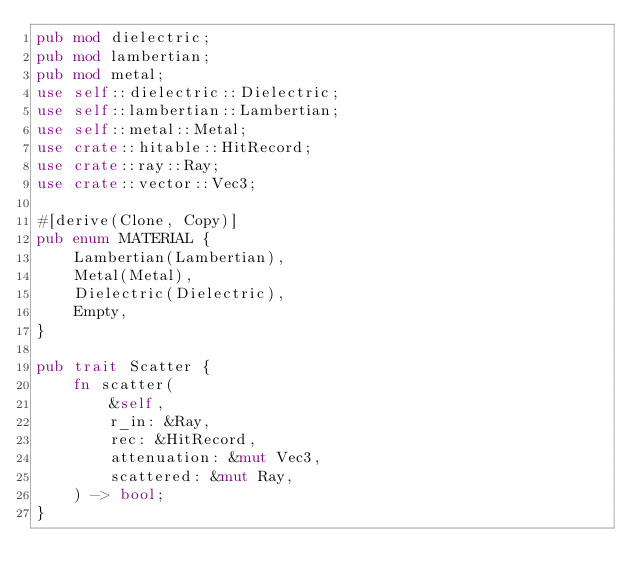Convert code to text. <code><loc_0><loc_0><loc_500><loc_500><_Rust_>pub mod dielectric;
pub mod lambertian;
pub mod metal;
use self::dielectric::Dielectric;
use self::lambertian::Lambertian;
use self::metal::Metal;
use crate::hitable::HitRecord;
use crate::ray::Ray;
use crate::vector::Vec3;

#[derive(Clone, Copy)]
pub enum MATERIAL {
    Lambertian(Lambertian),
    Metal(Metal),
    Dielectric(Dielectric),
    Empty,
}

pub trait Scatter {
    fn scatter(
        &self,
        r_in: &Ray,
        rec: &HitRecord,
        attenuation: &mut Vec3,
        scattered: &mut Ray,
    ) -> bool;
}
</code> 